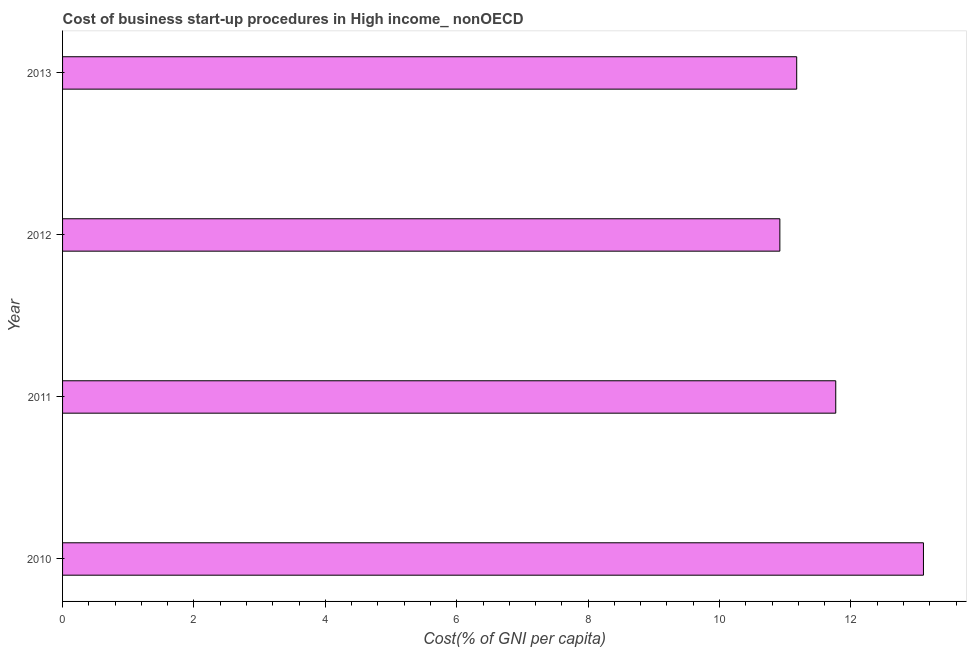What is the title of the graph?
Your response must be concise. Cost of business start-up procedures in High income_ nonOECD. What is the label or title of the X-axis?
Keep it short and to the point. Cost(% of GNI per capita). What is the cost of business startup procedures in 2013?
Offer a terse response. 11.18. Across all years, what is the maximum cost of business startup procedures?
Ensure brevity in your answer.  13.1. Across all years, what is the minimum cost of business startup procedures?
Ensure brevity in your answer.  10.92. What is the sum of the cost of business startup procedures?
Provide a succinct answer. 46.97. What is the difference between the cost of business startup procedures in 2012 and 2013?
Provide a short and direct response. -0.26. What is the average cost of business startup procedures per year?
Offer a terse response. 11.74. What is the median cost of business startup procedures?
Your response must be concise. 11.47. Do a majority of the years between 2010 and 2013 (inclusive) have cost of business startup procedures greater than 7.6 %?
Provide a short and direct response. Yes. What is the ratio of the cost of business startup procedures in 2011 to that in 2013?
Provide a short and direct response. 1.05. Is the difference between the cost of business startup procedures in 2011 and 2013 greater than the difference between any two years?
Provide a short and direct response. No. What is the difference between the highest and the second highest cost of business startup procedures?
Make the answer very short. 1.33. Is the sum of the cost of business startup procedures in 2011 and 2012 greater than the maximum cost of business startup procedures across all years?
Offer a very short reply. Yes. What is the difference between the highest and the lowest cost of business startup procedures?
Offer a terse response. 2.19. How many bars are there?
Give a very brief answer. 4. How many years are there in the graph?
Ensure brevity in your answer.  4. What is the difference between two consecutive major ticks on the X-axis?
Keep it short and to the point. 2. What is the Cost(% of GNI per capita) in 2010?
Provide a succinct answer. 13.1. What is the Cost(% of GNI per capita) in 2011?
Provide a short and direct response. 11.77. What is the Cost(% of GNI per capita) in 2012?
Ensure brevity in your answer.  10.92. What is the Cost(% of GNI per capita) in 2013?
Offer a terse response. 11.18. What is the difference between the Cost(% of GNI per capita) in 2010 and 2011?
Offer a terse response. 1.33. What is the difference between the Cost(% of GNI per capita) in 2010 and 2012?
Ensure brevity in your answer.  2.19. What is the difference between the Cost(% of GNI per capita) in 2010 and 2013?
Offer a terse response. 1.93. What is the difference between the Cost(% of GNI per capita) in 2011 and 2012?
Your answer should be very brief. 0.85. What is the difference between the Cost(% of GNI per capita) in 2011 and 2013?
Your answer should be very brief. 0.59. What is the difference between the Cost(% of GNI per capita) in 2012 and 2013?
Make the answer very short. -0.26. What is the ratio of the Cost(% of GNI per capita) in 2010 to that in 2011?
Offer a terse response. 1.11. What is the ratio of the Cost(% of GNI per capita) in 2010 to that in 2013?
Give a very brief answer. 1.17. What is the ratio of the Cost(% of GNI per capita) in 2011 to that in 2012?
Make the answer very short. 1.08. What is the ratio of the Cost(% of GNI per capita) in 2011 to that in 2013?
Provide a succinct answer. 1.05. 